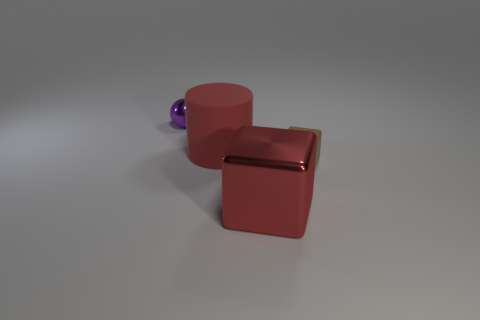Subtract 1 spheres. How many spheres are left? 0 Add 2 large green matte spheres. How many large green matte spheres exist? 2 Add 1 brown matte blocks. How many objects exist? 5 Subtract 1 red cubes. How many objects are left? 3 Subtract all cyan balls. Subtract all yellow cylinders. How many balls are left? 1 Subtract all red cylinders. How many green blocks are left? 0 Subtract all red matte cylinders. Subtract all red cylinders. How many objects are left? 2 Add 2 purple objects. How many purple objects are left? 3 